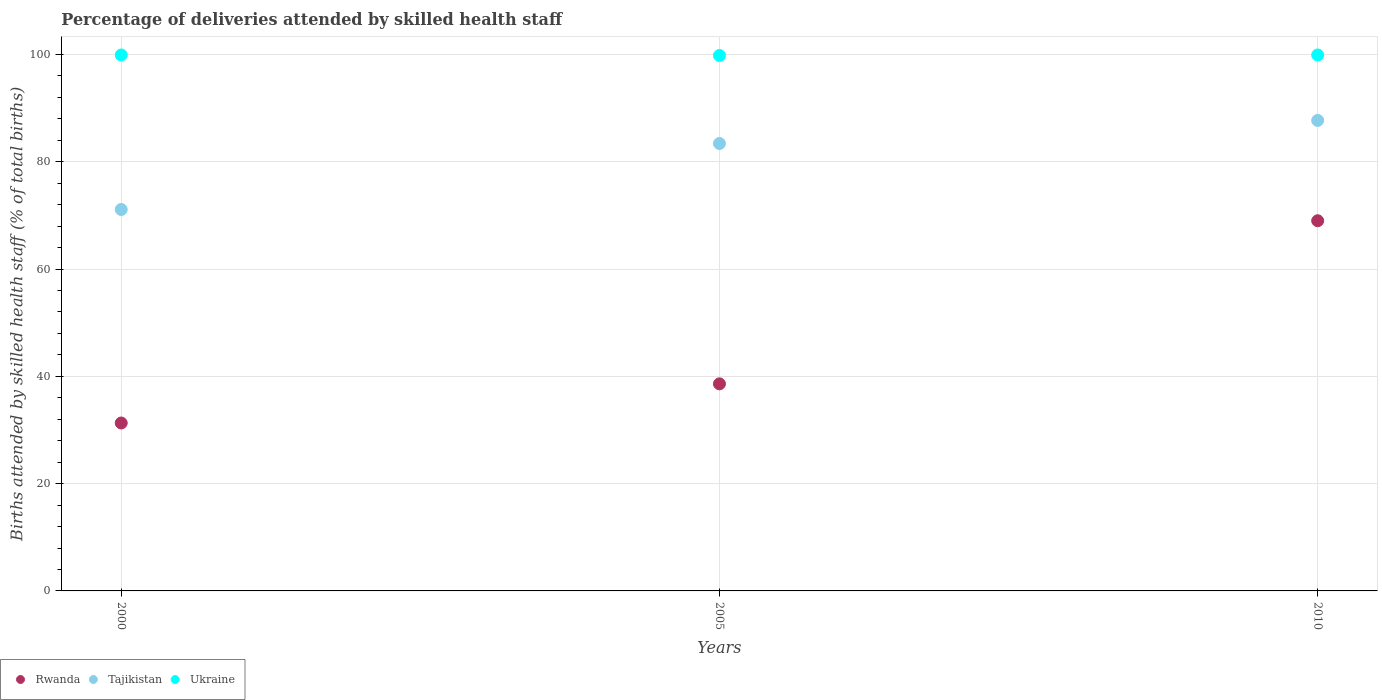How many different coloured dotlines are there?
Ensure brevity in your answer.  3. What is the percentage of births attended by skilled health staff in Tajikistan in 2000?
Provide a short and direct response. 71.1. Across all years, what is the maximum percentage of births attended by skilled health staff in Ukraine?
Keep it short and to the point. 99.9. Across all years, what is the minimum percentage of births attended by skilled health staff in Tajikistan?
Offer a terse response. 71.1. What is the total percentage of births attended by skilled health staff in Ukraine in the graph?
Keep it short and to the point. 299.6. What is the difference between the percentage of births attended by skilled health staff in Rwanda in 2000 and that in 2005?
Provide a succinct answer. -7.3. What is the difference between the percentage of births attended by skilled health staff in Tajikistan in 2005 and the percentage of births attended by skilled health staff in Rwanda in 2010?
Offer a terse response. 14.4. What is the average percentage of births attended by skilled health staff in Rwanda per year?
Provide a succinct answer. 46.3. In the year 2000, what is the difference between the percentage of births attended by skilled health staff in Ukraine and percentage of births attended by skilled health staff in Rwanda?
Your answer should be very brief. 68.6. What is the ratio of the percentage of births attended by skilled health staff in Ukraine in 2005 to that in 2010?
Give a very brief answer. 1. Is the percentage of births attended by skilled health staff in Ukraine in 2000 less than that in 2005?
Your answer should be compact. No. Is the difference between the percentage of births attended by skilled health staff in Ukraine in 2005 and 2010 greater than the difference between the percentage of births attended by skilled health staff in Rwanda in 2005 and 2010?
Your answer should be very brief. Yes. What is the difference between the highest and the second highest percentage of births attended by skilled health staff in Ukraine?
Offer a terse response. 0. What is the difference between the highest and the lowest percentage of births attended by skilled health staff in Tajikistan?
Provide a succinct answer. 16.6. In how many years, is the percentage of births attended by skilled health staff in Rwanda greater than the average percentage of births attended by skilled health staff in Rwanda taken over all years?
Give a very brief answer. 1. Does the percentage of births attended by skilled health staff in Ukraine monotonically increase over the years?
Your response must be concise. No. Is the percentage of births attended by skilled health staff in Ukraine strictly less than the percentage of births attended by skilled health staff in Tajikistan over the years?
Give a very brief answer. No. How many dotlines are there?
Your answer should be very brief. 3. Are the values on the major ticks of Y-axis written in scientific E-notation?
Keep it short and to the point. No. Does the graph contain grids?
Ensure brevity in your answer.  Yes. Where does the legend appear in the graph?
Provide a succinct answer. Bottom left. How many legend labels are there?
Provide a short and direct response. 3. How are the legend labels stacked?
Give a very brief answer. Horizontal. What is the title of the graph?
Offer a very short reply. Percentage of deliveries attended by skilled health staff. What is the label or title of the Y-axis?
Offer a terse response. Births attended by skilled health staff (% of total births). What is the Births attended by skilled health staff (% of total births) in Rwanda in 2000?
Your answer should be very brief. 31.3. What is the Births attended by skilled health staff (% of total births) in Tajikistan in 2000?
Your answer should be compact. 71.1. What is the Births attended by skilled health staff (% of total births) in Ukraine in 2000?
Give a very brief answer. 99.9. What is the Births attended by skilled health staff (% of total births) in Rwanda in 2005?
Provide a succinct answer. 38.6. What is the Births attended by skilled health staff (% of total births) in Tajikistan in 2005?
Ensure brevity in your answer.  83.4. What is the Births attended by skilled health staff (% of total births) in Ukraine in 2005?
Give a very brief answer. 99.8. What is the Births attended by skilled health staff (% of total births) of Rwanda in 2010?
Offer a terse response. 69. What is the Births attended by skilled health staff (% of total births) of Tajikistan in 2010?
Provide a short and direct response. 87.7. What is the Births attended by skilled health staff (% of total births) of Ukraine in 2010?
Give a very brief answer. 99.9. Across all years, what is the maximum Births attended by skilled health staff (% of total births) in Rwanda?
Give a very brief answer. 69. Across all years, what is the maximum Births attended by skilled health staff (% of total births) in Tajikistan?
Provide a succinct answer. 87.7. Across all years, what is the maximum Births attended by skilled health staff (% of total births) in Ukraine?
Give a very brief answer. 99.9. Across all years, what is the minimum Births attended by skilled health staff (% of total births) of Rwanda?
Give a very brief answer. 31.3. Across all years, what is the minimum Births attended by skilled health staff (% of total births) in Tajikistan?
Your answer should be very brief. 71.1. Across all years, what is the minimum Births attended by skilled health staff (% of total births) in Ukraine?
Provide a short and direct response. 99.8. What is the total Births attended by skilled health staff (% of total births) in Rwanda in the graph?
Ensure brevity in your answer.  138.9. What is the total Births attended by skilled health staff (% of total births) in Tajikistan in the graph?
Keep it short and to the point. 242.2. What is the total Births attended by skilled health staff (% of total births) in Ukraine in the graph?
Your answer should be compact. 299.6. What is the difference between the Births attended by skilled health staff (% of total births) in Tajikistan in 2000 and that in 2005?
Provide a short and direct response. -12.3. What is the difference between the Births attended by skilled health staff (% of total births) of Rwanda in 2000 and that in 2010?
Give a very brief answer. -37.7. What is the difference between the Births attended by skilled health staff (% of total births) of Tajikistan in 2000 and that in 2010?
Ensure brevity in your answer.  -16.6. What is the difference between the Births attended by skilled health staff (% of total births) in Rwanda in 2005 and that in 2010?
Your response must be concise. -30.4. What is the difference between the Births attended by skilled health staff (% of total births) in Tajikistan in 2005 and that in 2010?
Keep it short and to the point. -4.3. What is the difference between the Births attended by skilled health staff (% of total births) of Rwanda in 2000 and the Births attended by skilled health staff (% of total births) of Tajikistan in 2005?
Provide a short and direct response. -52.1. What is the difference between the Births attended by skilled health staff (% of total births) in Rwanda in 2000 and the Births attended by skilled health staff (% of total births) in Ukraine in 2005?
Your answer should be very brief. -68.5. What is the difference between the Births attended by skilled health staff (% of total births) of Tajikistan in 2000 and the Births attended by skilled health staff (% of total births) of Ukraine in 2005?
Provide a short and direct response. -28.7. What is the difference between the Births attended by skilled health staff (% of total births) of Rwanda in 2000 and the Births attended by skilled health staff (% of total births) of Tajikistan in 2010?
Provide a succinct answer. -56.4. What is the difference between the Births attended by skilled health staff (% of total births) in Rwanda in 2000 and the Births attended by skilled health staff (% of total births) in Ukraine in 2010?
Your answer should be very brief. -68.6. What is the difference between the Births attended by skilled health staff (% of total births) of Tajikistan in 2000 and the Births attended by skilled health staff (% of total births) of Ukraine in 2010?
Your answer should be compact. -28.8. What is the difference between the Births attended by skilled health staff (% of total births) of Rwanda in 2005 and the Births attended by skilled health staff (% of total births) of Tajikistan in 2010?
Make the answer very short. -49.1. What is the difference between the Births attended by skilled health staff (% of total births) in Rwanda in 2005 and the Births attended by skilled health staff (% of total births) in Ukraine in 2010?
Your answer should be compact. -61.3. What is the difference between the Births attended by skilled health staff (% of total births) of Tajikistan in 2005 and the Births attended by skilled health staff (% of total births) of Ukraine in 2010?
Offer a very short reply. -16.5. What is the average Births attended by skilled health staff (% of total births) in Rwanda per year?
Make the answer very short. 46.3. What is the average Births attended by skilled health staff (% of total births) of Tajikistan per year?
Give a very brief answer. 80.73. What is the average Births attended by skilled health staff (% of total births) of Ukraine per year?
Keep it short and to the point. 99.87. In the year 2000, what is the difference between the Births attended by skilled health staff (% of total births) of Rwanda and Births attended by skilled health staff (% of total births) of Tajikistan?
Make the answer very short. -39.8. In the year 2000, what is the difference between the Births attended by skilled health staff (% of total births) of Rwanda and Births attended by skilled health staff (% of total births) of Ukraine?
Your answer should be very brief. -68.6. In the year 2000, what is the difference between the Births attended by skilled health staff (% of total births) of Tajikistan and Births attended by skilled health staff (% of total births) of Ukraine?
Your answer should be compact. -28.8. In the year 2005, what is the difference between the Births attended by skilled health staff (% of total births) of Rwanda and Births attended by skilled health staff (% of total births) of Tajikistan?
Give a very brief answer. -44.8. In the year 2005, what is the difference between the Births attended by skilled health staff (% of total births) in Rwanda and Births attended by skilled health staff (% of total births) in Ukraine?
Make the answer very short. -61.2. In the year 2005, what is the difference between the Births attended by skilled health staff (% of total births) of Tajikistan and Births attended by skilled health staff (% of total births) of Ukraine?
Offer a very short reply. -16.4. In the year 2010, what is the difference between the Births attended by skilled health staff (% of total births) in Rwanda and Births attended by skilled health staff (% of total births) in Tajikistan?
Keep it short and to the point. -18.7. In the year 2010, what is the difference between the Births attended by skilled health staff (% of total births) in Rwanda and Births attended by skilled health staff (% of total births) in Ukraine?
Ensure brevity in your answer.  -30.9. In the year 2010, what is the difference between the Births attended by skilled health staff (% of total births) in Tajikistan and Births attended by skilled health staff (% of total births) in Ukraine?
Provide a short and direct response. -12.2. What is the ratio of the Births attended by skilled health staff (% of total births) of Rwanda in 2000 to that in 2005?
Offer a very short reply. 0.81. What is the ratio of the Births attended by skilled health staff (% of total births) in Tajikistan in 2000 to that in 2005?
Provide a succinct answer. 0.85. What is the ratio of the Births attended by skilled health staff (% of total births) in Ukraine in 2000 to that in 2005?
Provide a short and direct response. 1. What is the ratio of the Births attended by skilled health staff (% of total births) of Rwanda in 2000 to that in 2010?
Offer a terse response. 0.45. What is the ratio of the Births attended by skilled health staff (% of total births) of Tajikistan in 2000 to that in 2010?
Ensure brevity in your answer.  0.81. What is the ratio of the Births attended by skilled health staff (% of total births) in Ukraine in 2000 to that in 2010?
Offer a very short reply. 1. What is the ratio of the Births attended by skilled health staff (% of total births) of Rwanda in 2005 to that in 2010?
Your answer should be compact. 0.56. What is the ratio of the Births attended by skilled health staff (% of total births) in Tajikistan in 2005 to that in 2010?
Your response must be concise. 0.95. What is the difference between the highest and the second highest Births attended by skilled health staff (% of total births) in Rwanda?
Give a very brief answer. 30.4. What is the difference between the highest and the second highest Births attended by skilled health staff (% of total births) in Ukraine?
Ensure brevity in your answer.  0. What is the difference between the highest and the lowest Births attended by skilled health staff (% of total births) of Rwanda?
Make the answer very short. 37.7. What is the difference between the highest and the lowest Births attended by skilled health staff (% of total births) in Tajikistan?
Provide a succinct answer. 16.6. What is the difference between the highest and the lowest Births attended by skilled health staff (% of total births) of Ukraine?
Keep it short and to the point. 0.1. 